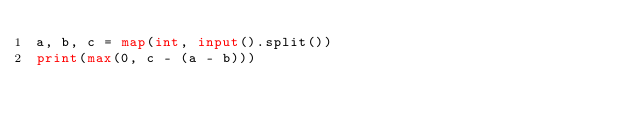<code> <loc_0><loc_0><loc_500><loc_500><_Python_>a, b, c = map(int, input().split())
print(max(0, c - (a - b)))</code> 